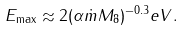<formula> <loc_0><loc_0><loc_500><loc_500>E _ { \max } \approx 2 ( \alpha \dot { m } M _ { 8 } ) ^ { - 0 . 3 } e V .</formula> 